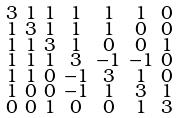<formula> <loc_0><loc_0><loc_500><loc_500>\begin{smallmatrix} 3 & 1 & 1 & 1 & 1 & 1 & 0 \\ 1 & 3 & 1 & 1 & 1 & 0 & 0 \\ 1 & 1 & 3 & 1 & 0 & 0 & 1 \\ 1 & 1 & 1 & 3 & - 1 & - 1 & 0 \\ 1 & 1 & 0 & - 1 & 3 & 1 & 0 \\ 1 & 0 & 0 & - 1 & 1 & 3 & 1 \\ 0 & 0 & 1 & 0 & 0 & 1 & 3 \end{smallmatrix}</formula> 